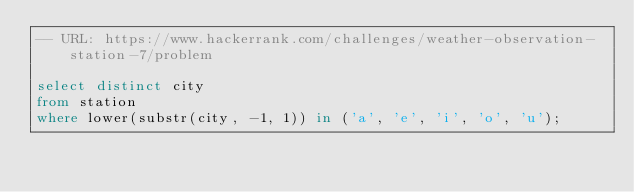<code> <loc_0><loc_0><loc_500><loc_500><_SQL_>-- URL: https://www.hackerrank.com/challenges/weather-observation-station-7/problem

select distinct city
from station
where lower(substr(city, -1, 1)) in ('a', 'e', 'i', 'o', 'u');
</code> 